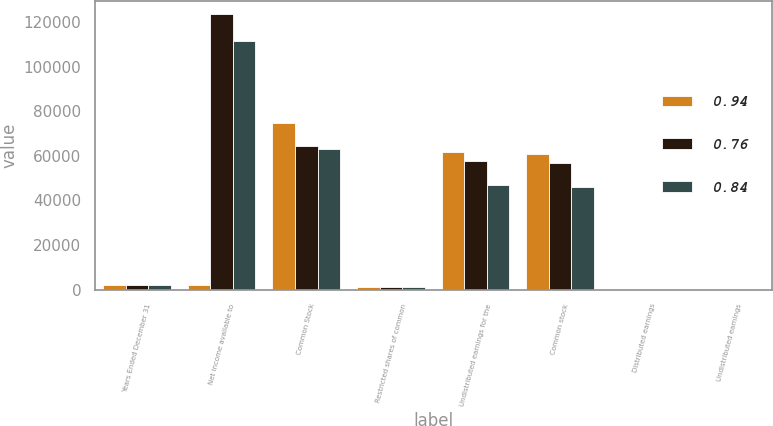<chart> <loc_0><loc_0><loc_500><loc_500><stacked_bar_chart><ecel><fcel>Years Ended December 31<fcel>Net income available to<fcel>Common Stock<fcel>Restricted shares of common<fcel>Undistributed earnings for the<fcel>Common stock<fcel>Distributed earnings<fcel>Undistributed earnings<nl><fcel>0.94<fcel>2014<fcel>2014<fcel>74704<fcel>1046<fcel>61914<fcel>61001<fcel>0.52<fcel>0.42<nl><fcel>0.76<fcel>2013<fcel>123330<fcel>64571<fcel>1087<fcel>57672<fcel>56663<fcel>0.45<fcel>0.39<nl><fcel>0.84<fcel>2012<fcel>111332<fcel>63120<fcel>1162<fcel>47050<fcel>46150<fcel>0.44<fcel>0.32<nl></chart> 